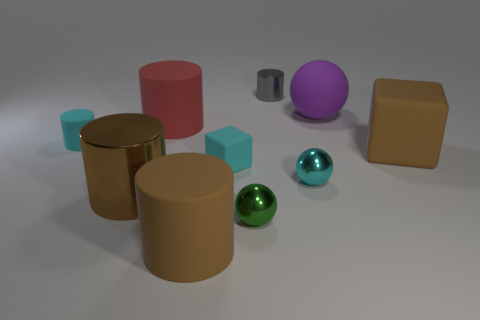The tiny rubber cylinder is what color?
Keep it short and to the point. Cyan. There is a brown object that is to the right of the tiny cyan rubber cube; what material is it?
Your response must be concise. Rubber. Do the cyan shiny object and the tiny metal thing left of the gray metallic cylinder have the same shape?
Ensure brevity in your answer.  Yes. Is the number of large brown rubber things greater than the number of gray shiny cylinders?
Keep it short and to the point. Yes. Is there anything else that has the same color as the matte ball?
Your response must be concise. No. The large purple object that is the same material as the red cylinder is what shape?
Your answer should be very brief. Sphere. There is a cyan block that is in front of the small cyan matte cylinder on the left side of the big matte block; what is its material?
Ensure brevity in your answer.  Rubber. There is a small matte object to the left of the big red rubber cylinder; is it the same shape as the gray metal object?
Keep it short and to the point. Yes. Are there more small cylinders that are left of the green metallic sphere than big blue matte blocks?
Your response must be concise. Yes. There is a rubber thing that is the same color as the small cube; what shape is it?
Your answer should be very brief. Cylinder. 